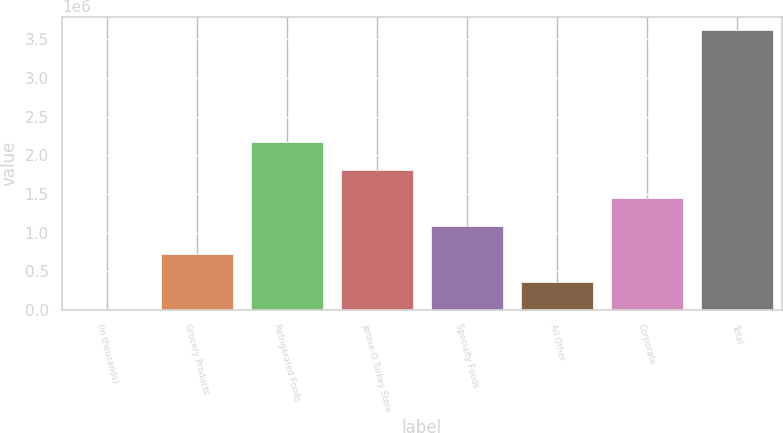<chart> <loc_0><loc_0><loc_500><loc_500><bar_chart><fcel>(in thousands)<fcel>Grocery Products<fcel>Refrigerated Foods<fcel>Jennie-O Turkey Store<fcel>Specialty Foods<fcel>All Other<fcel>Corporate<fcel>Total<nl><fcel>2008<fcel>724901<fcel>2.17069e+06<fcel>1.80924e+06<fcel>1.08635e+06<fcel>363454<fcel>1.44779e+06<fcel>3.61647e+06<nl></chart> 